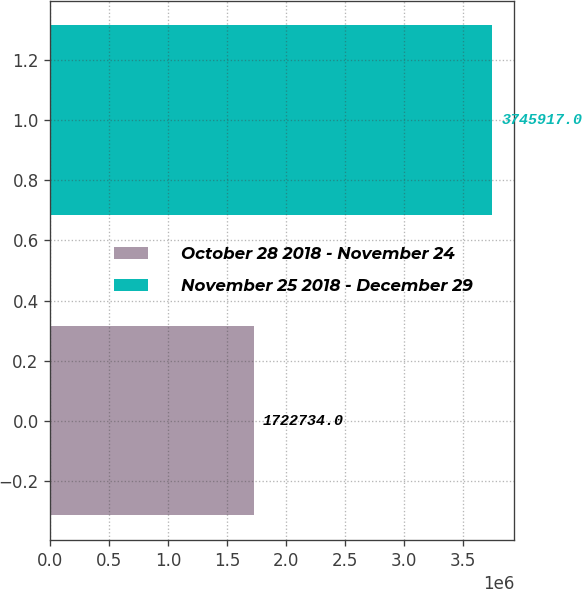Convert chart. <chart><loc_0><loc_0><loc_500><loc_500><bar_chart><fcel>October 28 2018 - November 24<fcel>November 25 2018 - December 29<nl><fcel>1.72273e+06<fcel>3.74592e+06<nl></chart> 